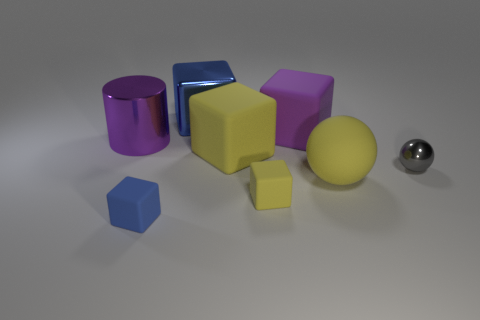Are there the same number of big objects left of the blue matte object and purple matte cubes behind the yellow sphere?
Make the answer very short. Yes. There is a matte object that is both on the right side of the tiny yellow matte block and in front of the purple metal object; what is its color?
Offer a terse response. Yellow. Is the number of yellow spheres that are right of the purple cube greater than the number of yellow rubber things that are in front of the tiny blue cube?
Provide a short and direct response. Yes. There is a blue block that is behind the purple rubber thing; does it have the same size as the metallic cylinder?
Your answer should be very brief. Yes. There is a yellow block that is in front of the large yellow thing that is on the left side of the matte sphere; what number of yellow spheres are to the left of it?
Your answer should be very brief. 0. How big is the matte block that is on the right side of the small blue block and in front of the tiny gray metallic object?
Offer a terse response. Small. What number of other things are the same shape as the blue metallic thing?
Make the answer very short. 4. There is a large yellow rubber block; what number of gray spheres are on the left side of it?
Ensure brevity in your answer.  0. Is the number of small gray metallic balls that are behind the purple matte thing less than the number of matte objects in front of the small yellow block?
Ensure brevity in your answer.  Yes. The large yellow rubber thing in front of the large matte object that is left of the tiny rubber cube right of the blue rubber object is what shape?
Your answer should be very brief. Sphere. 